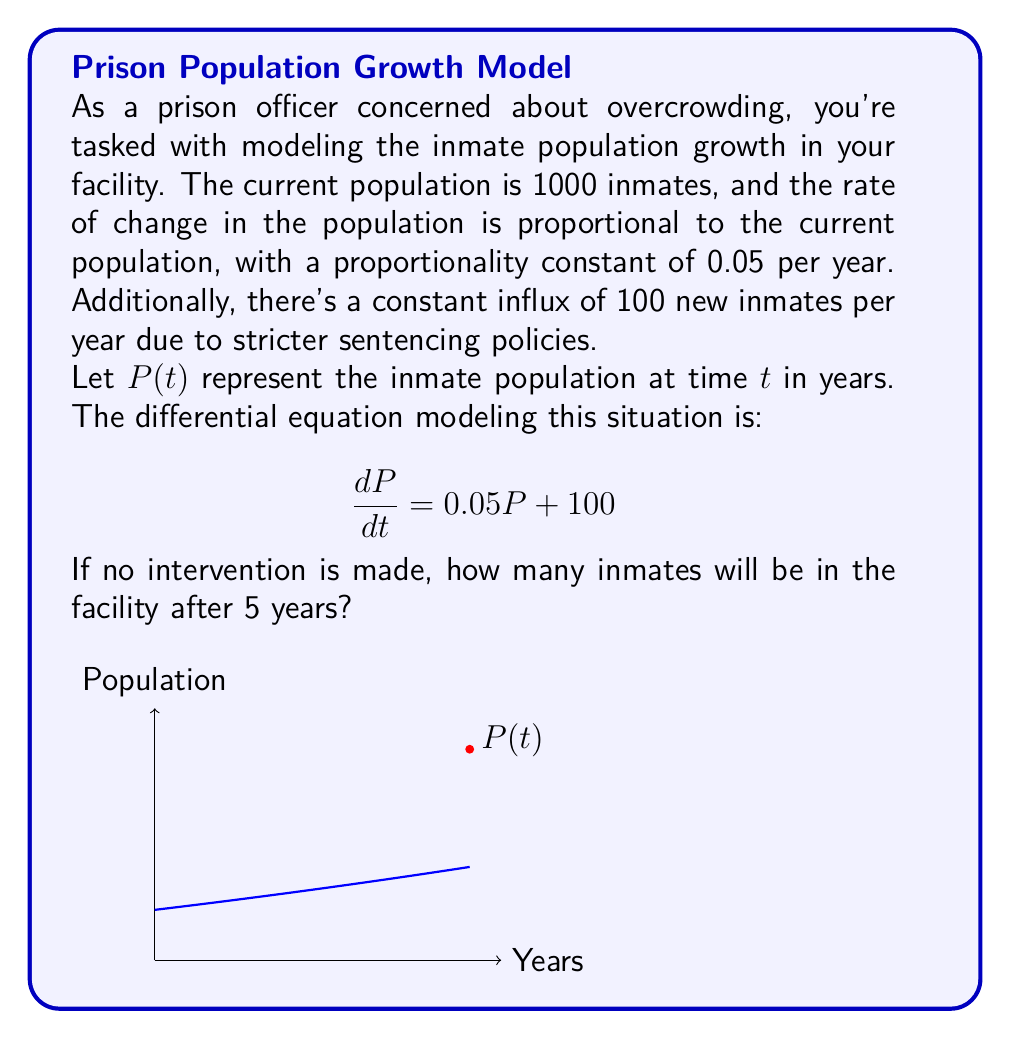Help me with this question. Let's solve this step-by-step:

1) The given differential equation is:

   $$\frac{dP}{dt} = 0.05P + 100$$

2) This is a first-order linear differential equation of the form:

   $$\frac{dP}{dt} + (-0.05)P = 100$$

3) The integrating factor is $e^{\int -0.05 dt} = e^{-0.05t}$

4) Multiplying both sides by the integrating factor:

   $$e^{-0.05t}\frac{dP}{dt} + (-0.05)e^{-0.05t}P = 100e^{-0.05t}$$

5) The left side is now the derivative of $e^{-0.05t}P$:

   $$\frac{d}{dt}(e^{-0.05t}P) = 100e^{-0.05t}$$

6) Integrating both sides:

   $$e^{-0.05t}P = -2000e^{-0.05t} + C$$

7) Solving for $P$:

   $$P(t) = -2000 + Ce^{0.05t}$$

8) Using the initial condition $P(0) = 1000$:

   $$1000 = -2000 + C$$
   $$C = 3000$$

9) Therefore, the general solution is:

   $$P(t) = -2000 + 3000e^{0.05t}$$

10) To find the population after 5 years, we calculate $P(5)$:

    $$P(5) = -2000 + 3000e^{0.05(5)}$$
    $$P(5) = -2000 + 3000e^{0.25}$$
    $$P(5) \approx 1847.92$$

11) Rounding to the nearest whole number (as we can't have fractional inmates):

    $$P(5) \approx 1848$$
Answer: 1848 inmates 